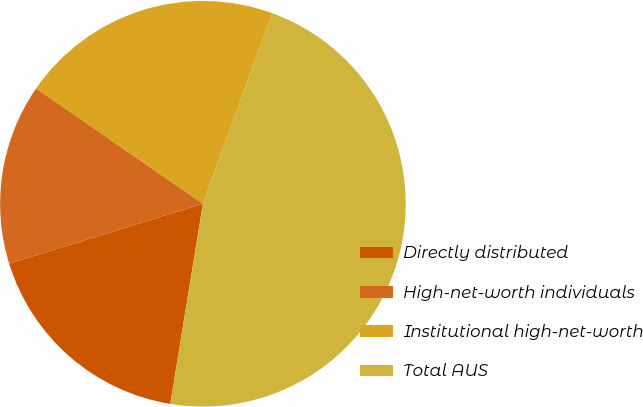Convert chart. <chart><loc_0><loc_0><loc_500><loc_500><pie_chart><fcel>Directly distributed<fcel>High-net-worth individuals<fcel>Institutional high-net-worth<fcel>Total AUS<nl><fcel>17.66%<fcel>14.4%<fcel>20.92%<fcel>47.02%<nl></chart> 